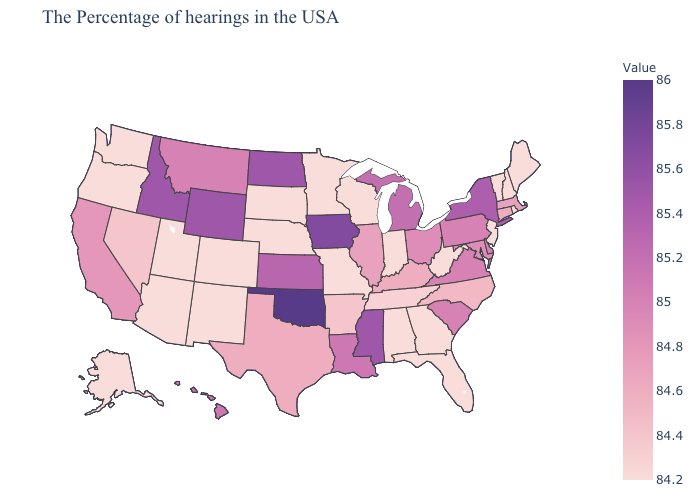Among the states that border Kansas , which have the lowest value?
Quick response, please. Missouri, Nebraska, Colorado. Does Utah have the lowest value in the USA?
Keep it brief. Yes. Which states have the lowest value in the Northeast?
Be succinct. Maine, Rhode Island, New Hampshire, Vermont, New Jersey. Does Pennsylvania have the lowest value in the Northeast?
Short answer required. No. Does Wisconsin have the lowest value in the MidWest?
Answer briefly. Yes. Which states have the highest value in the USA?
Concise answer only. Oklahoma. Does Arkansas have the highest value in the USA?
Keep it brief. No. 